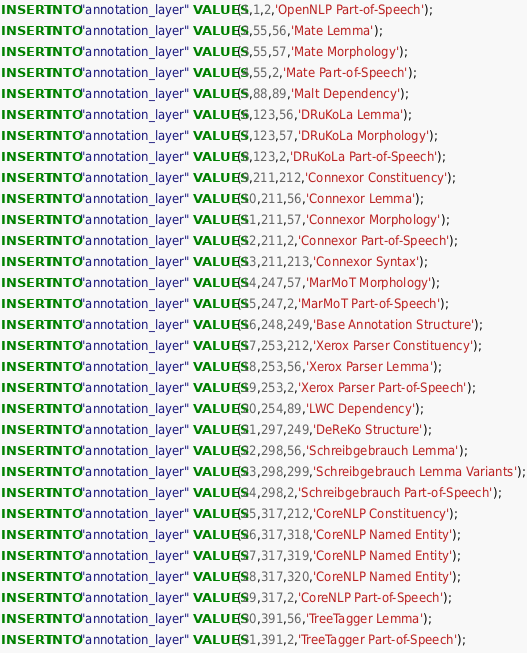Convert code to text. <code><loc_0><loc_0><loc_500><loc_500><_SQL_>INSERT INTO "annotation_layer" VALUES(1,1,2,'OpenNLP Part-of-Speech');
INSERT INTO "annotation_layer" VALUES(2,55,56,'Mate Lemma');
INSERT INTO "annotation_layer" VALUES(3,55,57,'Mate Morphology');
INSERT INTO "annotation_layer" VALUES(4,55,2,'Mate Part-of-Speech');
INSERT INTO "annotation_layer" VALUES(5,88,89,'Malt Dependency');
INSERT INTO "annotation_layer" VALUES(6,123,56,'DRuKoLa Lemma');
INSERT INTO "annotation_layer" VALUES(7,123,57,'DRuKoLa Morphology');
INSERT INTO "annotation_layer" VALUES(8,123,2,'DRuKoLa Part-of-Speech');
INSERT INTO "annotation_layer" VALUES(9,211,212,'Connexor Constituency');
INSERT INTO "annotation_layer" VALUES(10,211,56,'Connexor Lemma');
INSERT INTO "annotation_layer" VALUES(11,211,57,'Connexor Morphology');
INSERT INTO "annotation_layer" VALUES(12,211,2,'Connexor Part-of-Speech');
INSERT INTO "annotation_layer" VALUES(13,211,213,'Connexor Syntax');
INSERT INTO "annotation_layer" VALUES(14,247,57,'MarMoT Morphology');
INSERT INTO "annotation_layer" VALUES(15,247,2,'MarMoT Part-of-Speech');
INSERT INTO "annotation_layer" VALUES(16,248,249,'Base Annotation Structure');
INSERT INTO "annotation_layer" VALUES(17,253,212,'Xerox Parser Constituency');
INSERT INTO "annotation_layer" VALUES(18,253,56,'Xerox Parser Lemma');
INSERT INTO "annotation_layer" VALUES(19,253,2,'Xerox Parser Part-of-Speech');
INSERT INTO "annotation_layer" VALUES(20,254,89,'LWC Dependency');
INSERT INTO "annotation_layer" VALUES(21,297,249,'DeReKo Structure');
INSERT INTO "annotation_layer" VALUES(22,298,56,'Schreibgebrauch Lemma');
INSERT INTO "annotation_layer" VALUES(23,298,299,'Schreibgebrauch Lemma Variants');
INSERT INTO "annotation_layer" VALUES(24,298,2,'Schreibgebrauch Part-of-Speech');
INSERT INTO "annotation_layer" VALUES(25,317,212,'CoreNLP Constituency');
INSERT INTO "annotation_layer" VALUES(26,317,318,'CoreNLP Named Entity');
INSERT INTO "annotation_layer" VALUES(27,317,319,'CoreNLP Named Entity');
INSERT INTO "annotation_layer" VALUES(28,317,320,'CoreNLP Named Entity');
INSERT INTO "annotation_layer" VALUES(29,317,2,'CoreNLP Part-of-Speech');
INSERT INTO "annotation_layer" VALUES(30,391,56,'TreeTagger Lemma');
INSERT INTO "annotation_layer" VALUES(31,391,2,'TreeTagger Part-of-Speech');
</code> 